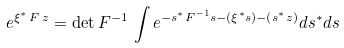<formula> <loc_0><loc_0><loc_500><loc_500>e ^ { { \xi } ^ { * } \, { F } \, { z } } = \det { F ^ { - 1 } } \, \int e ^ { - { s } ^ { * } { F } ^ { - 1 } { s } - ( { \xi } ^ { * } { s } ) - ( { s } ^ { * } { z } ) } d { s } ^ { * } d { s }</formula> 